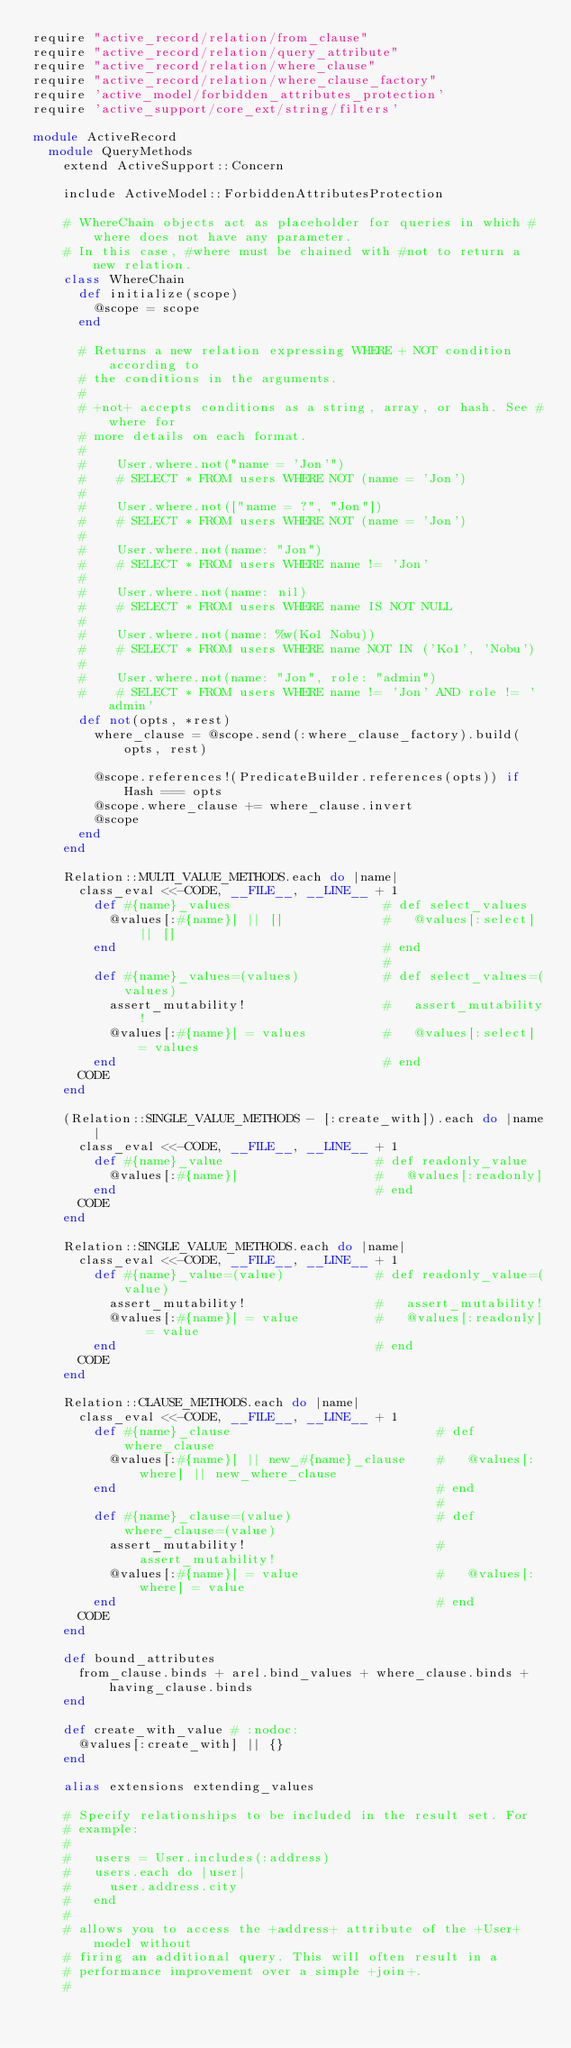<code> <loc_0><loc_0><loc_500><loc_500><_Ruby_>require "active_record/relation/from_clause"
require "active_record/relation/query_attribute"
require "active_record/relation/where_clause"
require "active_record/relation/where_clause_factory"
require 'active_model/forbidden_attributes_protection'
require 'active_support/core_ext/string/filters'

module ActiveRecord
  module QueryMethods
    extend ActiveSupport::Concern

    include ActiveModel::ForbiddenAttributesProtection

    # WhereChain objects act as placeholder for queries in which #where does not have any parameter.
    # In this case, #where must be chained with #not to return a new relation.
    class WhereChain
      def initialize(scope)
        @scope = scope
      end

      # Returns a new relation expressing WHERE + NOT condition according to
      # the conditions in the arguments.
      #
      # +not+ accepts conditions as a string, array, or hash. See #where for
      # more details on each format.
      #
      #    User.where.not("name = 'Jon'")
      #    # SELECT * FROM users WHERE NOT (name = 'Jon')
      #
      #    User.where.not(["name = ?", "Jon"])
      #    # SELECT * FROM users WHERE NOT (name = 'Jon')
      #
      #    User.where.not(name: "Jon")
      #    # SELECT * FROM users WHERE name != 'Jon'
      #
      #    User.where.not(name: nil)
      #    # SELECT * FROM users WHERE name IS NOT NULL
      #
      #    User.where.not(name: %w(Ko1 Nobu))
      #    # SELECT * FROM users WHERE name NOT IN ('Ko1', 'Nobu')
      #
      #    User.where.not(name: "Jon", role: "admin")
      #    # SELECT * FROM users WHERE name != 'Jon' AND role != 'admin'
      def not(opts, *rest)
        where_clause = @scope.send(:where_clause_factory).build(opts, rest)

        @scope.references!(PredicateBuilder.references(opts)) if Hash === opts
        @scope.where_clause += where_clause.invert
        @scope
      end
    end

    Relation::MULTI_VALUE_METHODS.each do |name|
      class_eval <<-CODE, __FILE__, __LINE__ + 1
        def #{name}_values                    # def select_values
          @values[:#{name}] || []             #   @values[:select] || []
        end                                   # end
                                              #
        def #{name}_values=(values)           # def select_values=(values)
          assert_mutability!                  #   assert_mutability!
          @values[:#{name}] = values          #   @values[:select] = values
        end                                   # end
      CODE
    end

    (Relation::SINGLE_VALUE_METHODS - [:create_with]).each do |name|
      class_eval <<-CODE, __FILE__, __LINE__ + 1
        def #{name}_value                    # def readonly_value
          @values[:#{name}]                  #   @values[:readonly]
        end                                  # end
      CODE
    end

    Relation::SINGLE_VALUE_METHODS.each do |name|
      class_eval <<-CODE, __FILE__, __LINE__ + 1
        def #{name}_value=(value)            # def readonly_value=(value)
          assert_mutability!                 #   assert_mutability!
          @values[:#{name}] = value          #   @values[:readonly] = value
        end                                  # end
      CODE
    end

    Relation::CLAUSE_METHODS.each do |name|
      class_eval <<-CODE, __FILE__, __LINE__ + 1
        def #{name}_clause                           # def where_clause
          @values[:#{name}] || new_#{name}_clause    #   @values[:where] || new_where_clause
        end                                          # end
                                                     #
        def #{name}_clause=(value)                   # def where_clause=(value)
          assert_mutability!                         #   assert_mutability!
          @values[:#{name}] = value                  #   @values[:where] = value
        end                                          # end
      CODE
    end

    def bound_attributes
      from_clause.binds + arel.bind_values + where_clause.binds + having_clause.binds
    end

    def create_with_value # :nodoc:
      @values[:create_with] || {}
    end

    alias extensions extending_values

    # Specify relationships to be included in the result set. For
    # example:
    #
    #   users = User.includes(:address)
    #   users.each do |user|
    #     user.address.city
    #   end
    #
    # allows you to access the +address+ attribute of the +User+ model without
    # firing an additional query. This will often result in a
    # performance improvement over a simple +join+.
    #</code> 